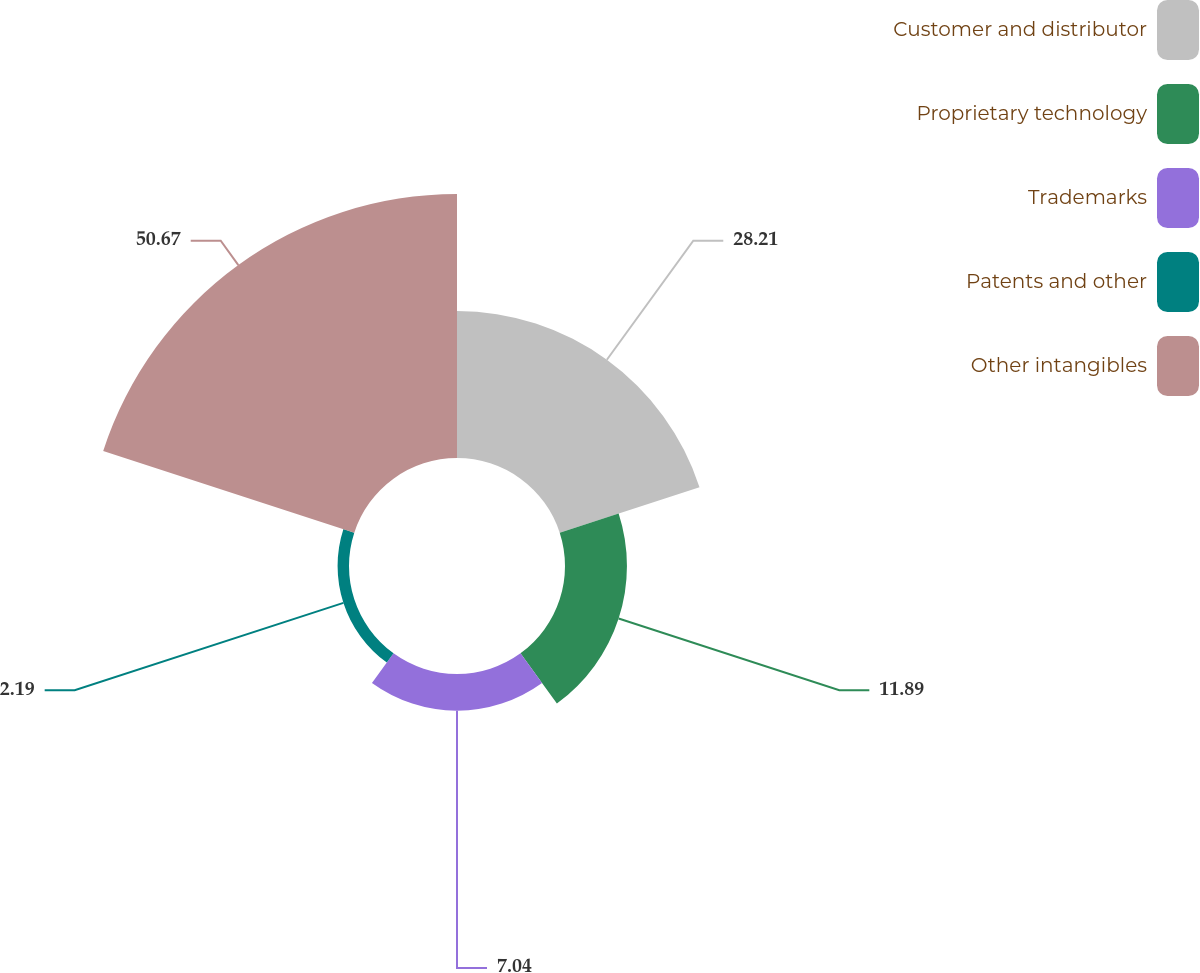Convert chart to OTSL. <chart><loc_0><loc_0><loc_500><loc_500><pie_chart><fcel>Customer and distributor<fcel>Proprietary technology<fcel>Trademarks<fcel>Patents and other<fcel>Other intangibles<nl><fcel>28.21%<fcel>11.89%<fcel>7.04%<fcel>2.19%<fcel>50.67%<nl></chart> 